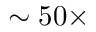Convert formula to latex. <formula><loc_0><loc_0><loc_500><loc_500>\sim 5 0 \times</formula> 